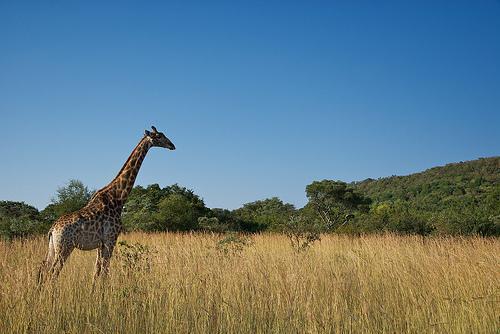How many birds are in the sky?
Give a very brief answer. 0. How many spotted animals are there?
Give a very brief answer. 1. 